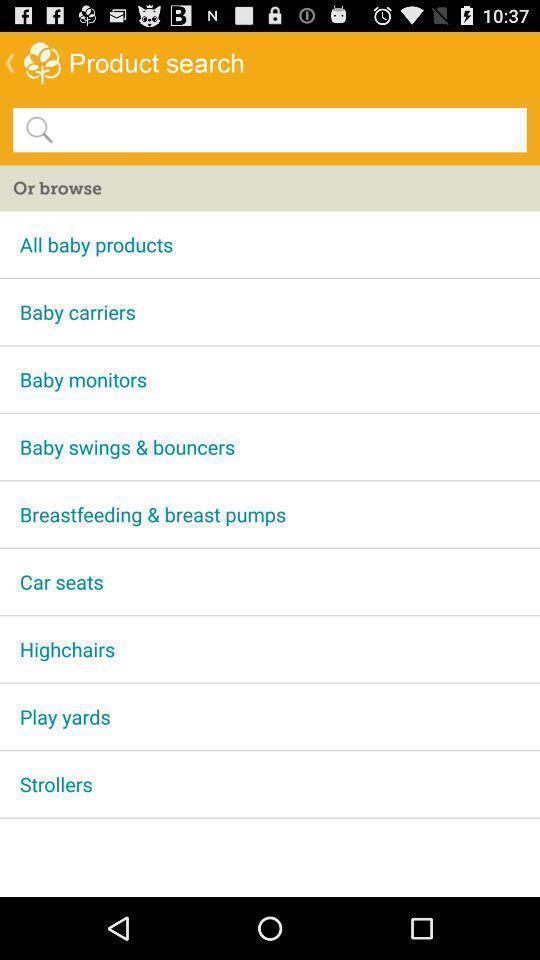Give me a narrative description of this picture. Shopping application displayed products search page. 